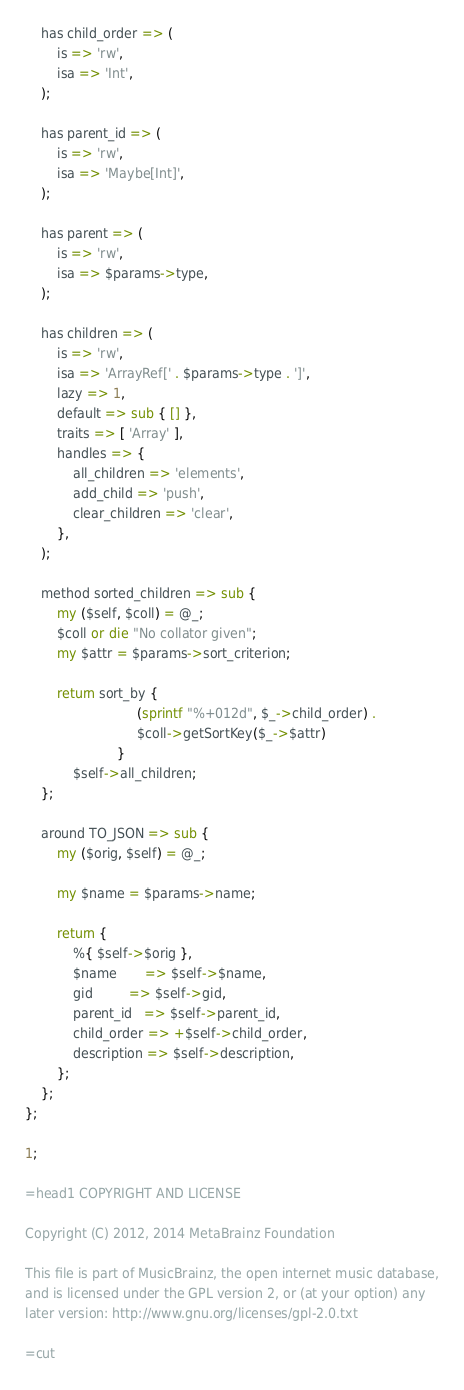Convert code to text. <code><loc_0><loc_0><loc_500><loc_500><_Perl_>    has child_order => (
        is => 'rw',
        isa => 'Int',
    );

    has parent_id => (
        is => 'rw',
        isa => 'Maybe[Int]',
    );

    has parent => (
        is => 'rw',
        isa => $params->type,
    );

    has children => (
        is => 'rw',
        isa => 'ArrayRef[' . $params->type . ']',
        lazy => 1,
        default => sub { [] },
        traits => [ 'Array' ],
        handles => {
            all_children => 'elements',
            add_child => 'push',
            clear_children => 'clear',
        },
    );

    method sorted_children => sub {
        my ($self, $coll) = @_;
        $coll or die "No collator given";
        my $attr = $params->sort_criterion;

        return sort_by {
                            (sprintf "%+012d", $_->child_order) .
                            $coll->getSortKey($_->$attr)
                       }
            $self->all_children;
    };

    around TO_JSON => sub {
        my ($orig, $self) = @_;

        my $name = $params->name;

        return {
            %{ $self->$orig },
            $name       => $self->$name,
            gid         => $self->gid,
            parent_id   => $self->parent_id,
            child_order => +$self->child_order,
            description => $self->description,
        };
    };
};

1;

=head1 COPYRIGHT AND LICENSE

Copyright (C) 2012, 2014 MetaBrainz Foundation

This file is part of MusicBrainz, the open internet music database,
and is licensed under the GPL version 2, or (at your option) any
later version: http://www.gnu.org/licenses/gpl-2.0.txt

=cut
</code> 